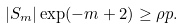<formula> <loc_0><loc_0><loc_500><loc_500>| S _ { m } | \exp ( - m + 2 ) \geq \rho p .</formula> 